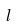<formula> <loc_0><loc_0><loc_500><loc_500>l</formula> 